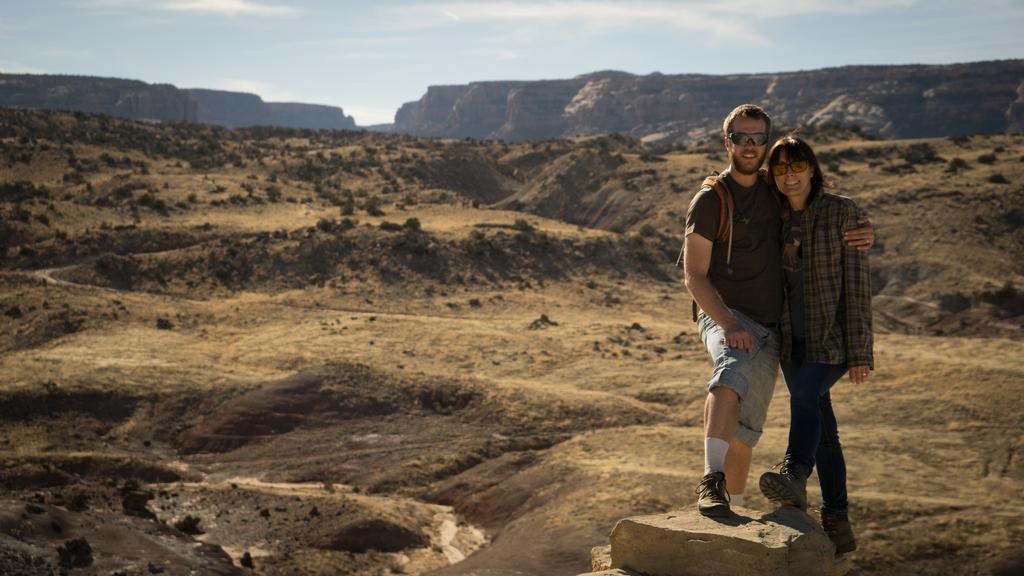Describe this image in one or two sentences. In this image I can see two people are standing and wearing the different color dresses. I can also see these people are wearing the goggles. In the back I can see the small trees, mountains and the sky 